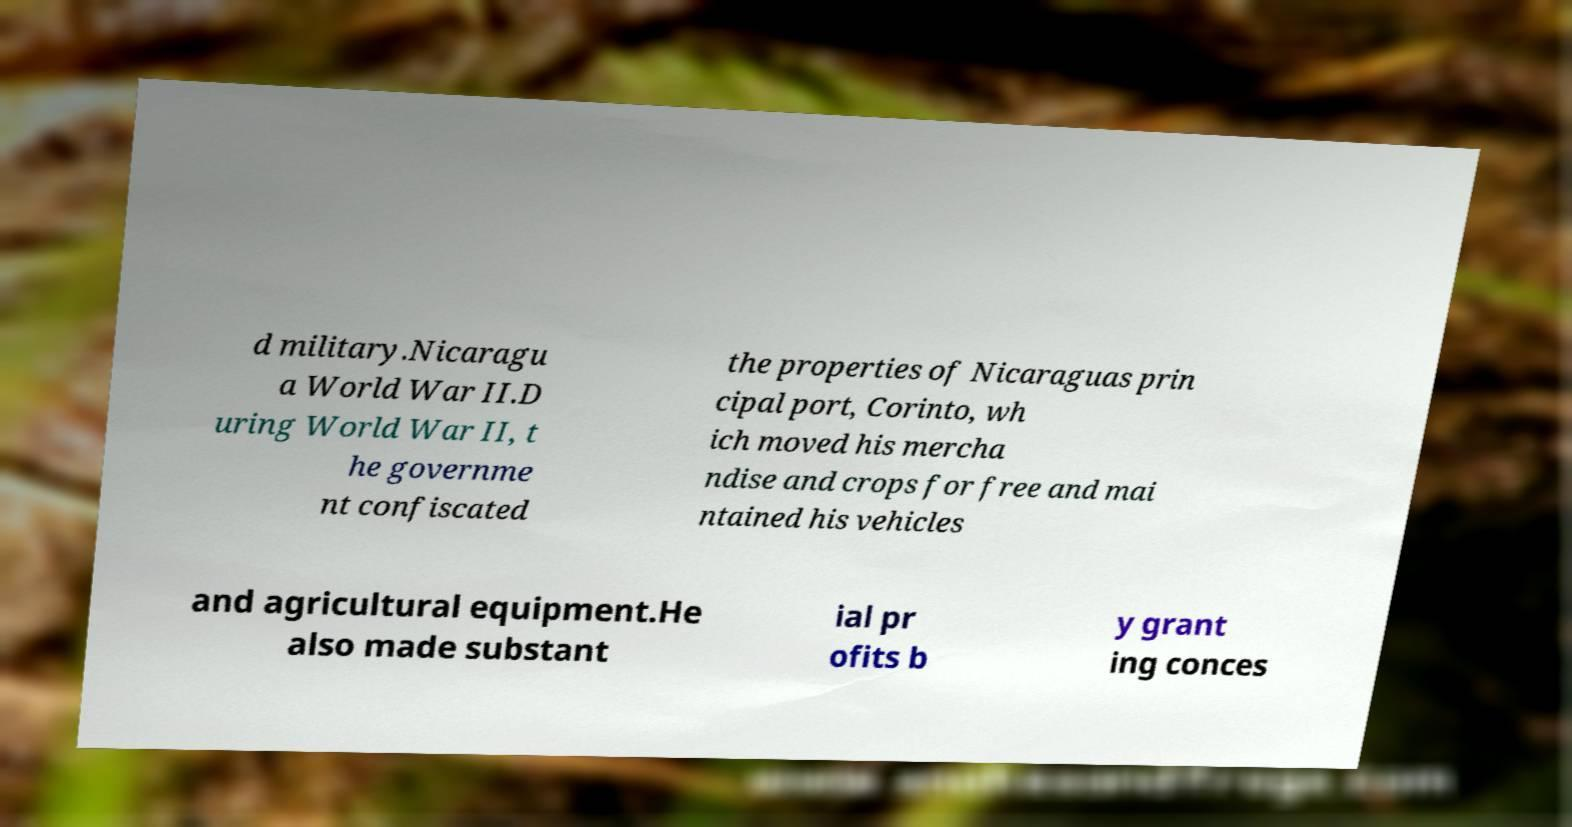Can you read and provide the text displayed in the image?This photo seems to have some interesting text. Can you extract and type it out for me? d military.Nicaragu a World War II.D uring World War II, t he governme nt confiscated the properties of Nicaraguas prin cipal port, Corinto, wh ich moved his mercha ndise and crops for free and mai ntained his vehicles and agricultural equipment.He also made substant ial pr ofits b y grant ing conces 